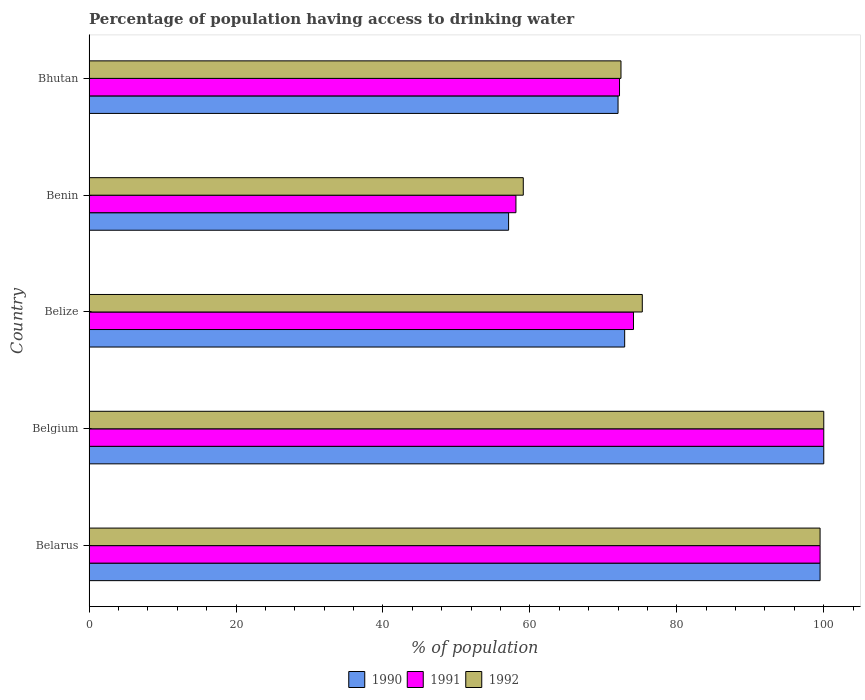Are the number of bars on each tick of the Y-axis equal?
Provide a short and direct response. Yes. What is the label of the 1st group of bars from the top?
Give a very brief answer. Bhutan. In how many cases, is the number of bars for a given country not equal to the number of legend labels?
Ensure brevity in your answer.  0. What is the percentage of population having access to drinking water in 1991 in Belgium?
Your answer should be very brief. 100. Across all countries, what is the maximum percentage of population having access to drinking water in 1990?
Ensure brevity in your answer.  100. Across all countries, what is the minimum percentage of population having access to drinking water in 1990?
Make the answer very short. 57.1. In which country was the percentage of population having access to drinking water in 1991 maximum?
Your answer should be very brief. Belgium. In which country was the percentage of population having access to drinking water in 1991 minimum?
Your answer should be compact. Benin. What is the total percentage of population having access to drinking water in 1992 in the graph?
Provide a short and direct response. 406.3. What is the difference between the percentage of population having access to drinking water in 1991 in Belize and that in Bhutan?
Provide a short and direct response. 1.9. What is the difference between the percentage of population having access to drinking water in 1991 in Bhutan and the percentage of population having access to drinking water in 1990 in Belize?
Keep it short and to the point. -0.7. What is the average percentage of population having access to drinking water in 1990 per country?
Give a very brief answer. 80.3. What is the difference between the percentage of population having access to drinking water in 1992 and percentage of population having access to drinking water in 1990 in Belgium?
Your answer should be compact. 0. In how many countries, is the percentage of population having access to drinking water in 1991 greater than 100 %?
Your response must be concise. 0. What is the ratio of the percentage of population having access to drinking water in 1990 in Belarus to that in Bhutan?
Your answer should be compact. 1.38. Is the difference between the percentage of population having access to drinking water in 1992 in Belarus and Benin greater than the difference between the percentage of population having access to drinking water in 1990 in Belarus and Benin?
Provide a succinct answer. No. What is the difference between the highest and the second highest percentage of population having access to drinking water in 1991?
Ensure brevity in your answer.  0.5. What is the difference between the highest and the lowest percentage of population having access to drinking water in 1991?
Your answer should be compact. 41.9. In how many countries, is the percentage of population having access to drinking water in 1992 greater than the average percentage of population having access to drinking water in 1992 taken over all countries?
Your response must be concise. 2. What does the 2nd bar from the top in Bhutan represents?
Keep it short and to the point. 1991. Is it the case that in every country, the sum of the percentage of population having access to drinking water in 1991 and percentage of population having access to drinking water in 1990 is greater than the percentage of population having access to drinking water in 1992?
Provide a short and direct response. Yes. How many bars are there?
Your answer should be very brief. 15. Are all the bars in the graph horizontal?
Keep it short and to the point. Yes. What is the difference between two consecutive major ticks on the X-axis?
Provide a succinct answer. 20. Where does the legend appear in the graph?
Offer a very short reply. Bottom center. How are the legend labels stacked?
Provide a succinct answer. Horizontal. What is the title of the graph?
Ensure brevity in your answer.  Percentage of population having access to drinking water. Does "1968" appear as one of the legend labels in the graph?
Give a very brief answer. No. What is the label or title of the X-axis?
Your answer should be very brief. % of population. What is the label or title of the Y-axis?
Your answer should be compact. Country. What is the % of population in 1990 in Belarus?
Offer a terse response. 99.5. What is the % of population of 1991 in Belarus?
Ensure brevity in your answer.  99.5. What is the % of population in 1992 in Belarus?
Your answer should be compact. 99.5. What is the % of population of 1990 in Belgium?
Provide a succinct answer. 100. What is the % of population in 1991 in Belgium?
Keep it short and to the point. 100. What is the % of population in 1990 in Belize?
Your answer should be very brief. 72.9. What is the % of population in 1991 in Belize?
Keep it short and to the point. 74.1. What is the % of population in 1992 in Belize?
Your answer should be very brief. 75.3. What is the % of population of 1990 in Benin?
Provide a succinct answer. 57.1. What is the % of population in 1991 in Benin?
Ensure brevity in your answer.  58.1. What is the % of population of 1992 in Benin?
Make the answer very short. 59.1. What is the % of population in 1991 in Bhutan?
Ensure brevity in your answer.  72.2. What is the % of population in 1992 in Bhutan?
Your answer should be compact. 72.4. Across all countries, what is the maximum % of population in 1990?
Your answer should be compact. 100. Across all countries, what is the minimum % of population in 1990?
Ensure brevity in your answer.  57.1. Across all countries, what is the minimum % of population in 1991?
Give a very brief answer. 58.1. Across all countries, what is the minimum % of population in 1992?
Offer a terse response. 59.1. What is the total % of population of 1990 in the graph?
Make the answer very short. 401.5. What is the total % of population of 1991 in the graph?
Provide a succinct answer. 403.9. What is the total % of population of 1992 in the graph?
Your response must be concise. 406.3. What is the difference between the % of population in 1990 in Belarus and that in Belgium?
Your answer should be compact. -0.5. What is the difference between the % of population of 1991 in Belarus and that in Belgium?
Offer a terse response. -0.5. What is the difference between the % of population in 1990 in Belarus and that in Belize?
Provide a short and direct response. 26.6. What is the difference between the % of population in 1991 in Belarus and that in Belize?
Provide a short and direct response. 25.4. What is the difference between the % of population in 1992 in Belarus and that in Belize?
Keep it short and to the point. 24.2. What is the difference between the % of population in 1990 in Belarus and that in Benin?
Ensure brevity in your answer.  42.4. What is the difference between the % of population of 1991 in Belarus and that in Benin?
Offer a very short reply. 41.4. What is the difference between the % of population of 1992 in Belarus and that in Benin?
Provide a succinct answer. 40.4. What is the difference between the % of population in 1990 in Belarus and that in Bhutan?
Make the answer very short. 27.5. What is the difference between the % of population in 1991 in Belarus and that in Bhutan?
Provide a short and direct response. 27.3. What is the difference between the % of population of 1992 in Belarus and that in Bhutan?
Provide a succinct answer. 27.1. What is the difference between the % of population of 1990 in Belgium and that in Belize?
Offer a terse response. 27.1. What is the difference between the % of population of 1991 in Belgium and that in Belize?
Make the answer very short. 25.9. What is the difference between the % of population of 1992 in Belgium and that in Belize?
Provide a succinct answer. 24.7. What is the difference between the % of population of 1990 in Belgium and that in Benin?
Provide a succinct answer. 42.9. What is the difference between the % of population in 1991 in Belgium and that in Benin?
Provide a short and direct response. 41.9. What is the difference between the % of population in 1992 in Belgium and that in Benin?
Provide a succinct answer. 40.9. What is the difference between the % of population in 1991 in Belgium and that in Bhutan?
Provide a short and direct response. 27.8. What is the difference between the % of population of 1992 in Belgium and that in Bhutan?
Your answer should be very brief. 27.6. What is the difference between the % of population in 1991 in Belize and that in Benin?
Your answer should be compact. 16. What is the difference between the % of population of 1990 in Belize and that in Bhutan?
Provide a short and direct response. 0.9. What is the difference between the % of population of 1991 in Belize and that in Bhutan?
Keep it short and to the point. 1.9. What is the difference between the % of population of 1990 in Benin and that in Bhutan?
Offer a terse response. -14.9. What is the difference between the % of population of 1991 in Benin and that in Bhutan?
Your answer should be compact. -14.1. What is the difference between the % of population of 1990 in Belarus and the % of population of 1991 in Belize?
Offer a terse response. 25.4. What is the difference between the % of population in 1990 in Belarus and the % of population in 1992 in Belize?
Your response must be concise. 24.2. What is the difference between the % of population in 1991 in Belarus and the % of population in 1992 in Belize?
Your response must be concise. 24.2. What is the difference between the % of population in 1990 in Belarus and the % of population in 1991 in Benin?
Offer a terse response. 41.4. What is the difference between the % of population in 1990 in Belarus and the % of population in 1992 in Benin?
Offer a terse response. 40.4. What is the difference between the % of population in 1991 in Belarus and the % of population in 1992 in Benin?
Provide a short and direct response. 40.4. What is the difference between the % of population in 1990 in Belarus and the % of population in 1991 in Bhutan?
Your response must be concise. 27.3. What is the difference between the % of population of 1990 in Belarus and the % of population of 1992 in Bhutan?
Ensure brevity in your answer.  27.1. What is the difference between the % of population in 1991 in Belarus and the % of population in 1992 in Bhutan?
Give a very brief answer. 27.1. What is the difference between the % of population in 1990 in Belgium and the % of population in 1991 in Belize?
Ensure brevity in your answer.  25.9. What is the difference between the % of population of 1990 in Belgium and the % of population of 1992 in Belize?
Offer a terse response. 24.7. What is the difference between the % of population of 1991 in Belgium and the % of population of 1992 in Belize?
Ensure brevity in your answer.  24.7. What is the difference between the % of population in 1990 in Belgium and the % of population in 1991 in Benin?
Keep it short and to the point. 41.9. What is the difference between the % of population in 1990 in Belgium and the % of population in 1992 in Benin?
Offer a very short reply. 40.9. What is the difference between the % of population in 1991 in Belgium and the % of population in 1992 in Benin?
Offer a very short reply. 40.9. What is the difference between the % of population of 1990 in Belgium and the % of population of 1991 in Bhutan?
Provide a short and direct response. 27.8. What is the difference between the % of population in 1990 in Belgium and the % of population in 1992 in Bhutan?
Keep it short and to the point. 27.6. What is the difference between the % of population in 1991 in Belgium and the % of population in 1992 in Bhutan?
Offer a terse response. 27.6. What is the difference between the % of population in 1990 in Belize and the % of population in 1992 in Bhutan?
Make the answer very short. 0.5. What is the difference between the % of population of 1990 in Benin and the % of population of 1991 in Bhutan?
Ensure brevity in your answer.  -15.1. What is the difference between the % of population of 1990 in Benin and the % of population of 1992 in Bhutan?
Provide a succinct answer. -15.3. What is the difference between the % of population of 1991 in Benin and the % of population of 1992 in Bhutan?
Provide a short and direct response. -14.3. What is the average % of population in 1990 per country?
Offer a very short reply. 80.3. What is the average % of population of 1991 per country?
Keep it short and to the point. 80.78. What is the average % of population in 1992 per country?
Offer a very short reply. 81.26. What is the difference between the % of population in 1990 and % of population in 1991 in Belarus?
Your answer should be compact. 0. What is the difference between the % of population of 1991 and % of population of 1992 in Belarus?
Your answer should be compact. 0. What is the difference between the % of population in 1990 and % of population in 1991 in Belgium?
Offer a very short reply. 0. What is the difference between the % of population in 1991 and % of population in 1992 in Belgium?
Make the answer very short. 0. What is the difference between the % of population of 1990 and % of population of 1991 in Benin?
Provide a short and direct response. -1. What is the difference between the % of population in 1990 and % of population in 1992 in Bhutan?
Give a very brief answer. -0.4. What is the ratio of the % of population in 1990 in Belarus to that in Belgium?
Offer a terse response. 0.99. What is the ratio of the % of population in 1992 in Belarus to that in Belgium?
Give a very brief answer. 0.99. What is the ratio of the % of population in 1990 in Belarus to that in Belize?
Provide a succinct answer. 1.36. What is the ratio of the % of population in 1991 in Belarus to that in Belize?
Offer a terse response. 1.34. What is the ratio of the % of population of 1992 in Belarus to that in Belize?
Provide a short and direct response. 1.32. What is the ratio of the % of population of 1990 in Belarus to that in Benin?
Provide a succinct answer. 1.74. What is the ratio of the % of population in 1991 in Belarus to that in Benin?
Offer a terse response. 1.71. What is the ratio of the % of population of 1992 in Belarus to that in Benin?
Your answer should be very brief. 1.68. What is the ratio of the % of population of 1990 in Belarus to that in Bhutan?
Offer a very short reply. 1.38. What is the ratio of the % of population in 1991 in Belarus to that in Bhutan?
Keep it short and to the point. 1.38. What is the ratio of the % of population in 1992 in Belarus to that in Bhutan?
Ensure brevity in your answer.  1.37. What is the ratio of the % of population in 1990 in Belgium to that in Belize?
Your response must be concise. 1.37. What is the ratio of the % of population of 1991 in Belgium to that in Belize?
Your response must be concise. 1.35. What is the ratio of the % of population in 1992 in Belgium to that in Belize?
Offer a very short reply. 1.33. What is the ratio of the % of population in 1990 in Belgium to that in Benin?
Give a very brief answer. 1.75. What is the ratio of the % of population of 1991 in Belgium to that in Benin?
Give a very brief answer. 1.72. What is the ratio of the % of population of 1992 in Belgium to that in Benin?
Ensure brevity in your answer.  1.69. What is the ratio of the % of population of 1990 in Belgium to that in Bhutan?
Offer a very short reply. 1.39. What is the ratio of the % of population in 1991 in Belgium to that in Bhutan?
Make the answer very short. 1.39. What is the ratio of the % of population of 1992 in Belgium to that in Bhutan?
Provide a succinct answer. 1.38. What is the ratio of the % of population in 1990 in Belize to that in Benin?
Keep it short and to the point. 1.28. What is the ratio of the % of population of 1991 in Belize to that in Benin?
Offer a very short reply. 1.28. What is the ratio of the % of population in 1992 in Belize to that in Benin?
Offer a very short reply. 1.27. What is the ratio of the % of population of 1990 in Belize to that in Bhutan?
Provide a short and direct response. 1.01. What is the ratio of the % of population of 1991 in Belize to that in Bhutan?
Offer a very short reply. 1.03. What is the ratio of the % of population of 1992 in Belize to that in Bhutan?
Provide a succinct answer. 1.04. What is the ratio of the % of population in 1990 in Benin to that in Bhutan?
Offer a terse response. 0.79. What is the ratio of the % of population of 1991 in Benin to that in Bhutan?
Give a very brief answer. 0.8. What is the ratio of the % of population in 1992 in Benin to that in Bhutan?
Give a very brief answer. 0.82. What is the difference between the highest and the second highest % of population in 1990?
Your answer should be very brief. 0.5. What is the difference between the highest and the lowest % of population in 1990?
Offer a very short reply. 42.9. What is the difference between the highest and the lowest % of population of 1991?
Provide a succinct answer. 41.9. What is the difference between the highest and the lowest % of population in 1992?
Offer a very short reply. 40.9. 